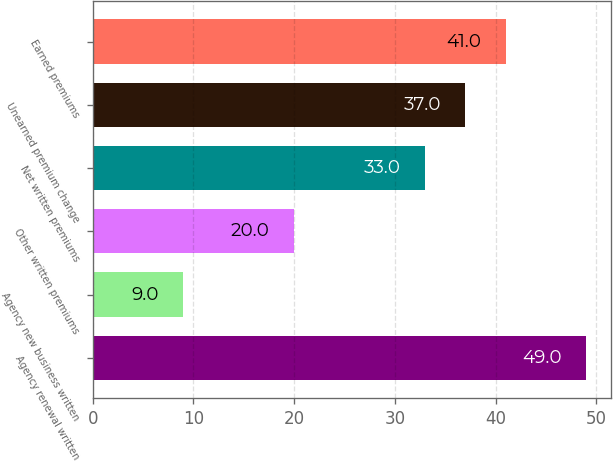<chart> <loc_0><loc_0><loc_500><loc_500><bar_chart><fcel>Agency renewal written<fcel>Agency new business written<fcel>Other written premiums<fcel>Net written premiums<fcel>Unearned premium change<fcel>Earned premiums<nl><fcel>49<fcel>9<fcel>20<fcel>33<fcel>37<fcel>41<nl></chart> 